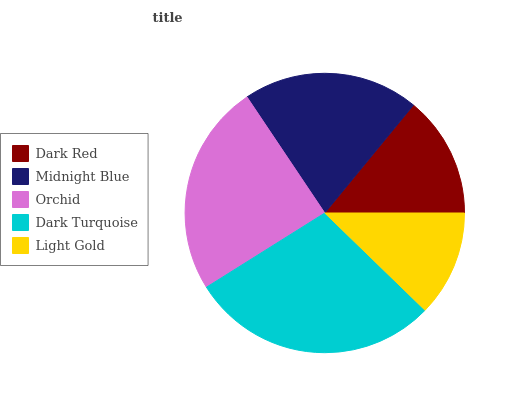Is Light Gold the minimum?
Answer yes or no. Yes. Is Dark Turquoise the maximum?
Answer yes or no. Yes. Is Midnight Blue the minimum?
Answer yes or no. No. Is Midnight Blue the maximum?
Answer yes or no. No. Is Midnight Blue greater than Dark Red?
Answer yes or no. Yes. Is Dark Red less than Midnight Blue?
Answer yes or no. Yes. Is Dark Red greater than Midnight Blue?
Answer yes or no. No. Is Midnight Blue less than Dark Red?
Answer yes or no. No. Is Midnight Blue the high median?
Answer yes or no. Yes. Is Midnight Blue the low median?
Answer yes or no. Yes. Is Light Gold the high median?
Answer yes or no. No. Is Dark Red the low median?
Answer yes or no. No. 